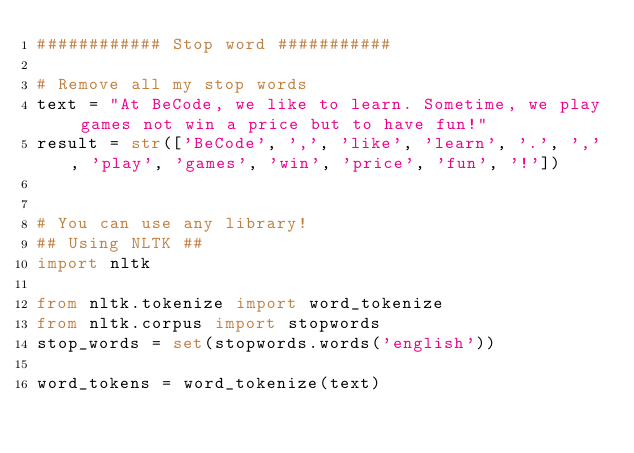<code> <loc_0><loc_0><loc_500><loc_500><_Python_>############ Stop word ###########

# Remove all my stop words
text = "At BeCode, we like to learn. Sometime, we play games not win a price but to have fun!"
result = str(['BeCode', ',', 'like', 'learn', '.', ',', 'play', 'games', 'win', 'price', 'fun', '!'])


# You can use any library!
## Using NLTK ##
import nltk

from nltk.tokenize import word_tokenize
from nltk.corpus import stopwords
stop_words = set(stopwords.words('english'))

word_tokens = word_tokenize(text)</code> 